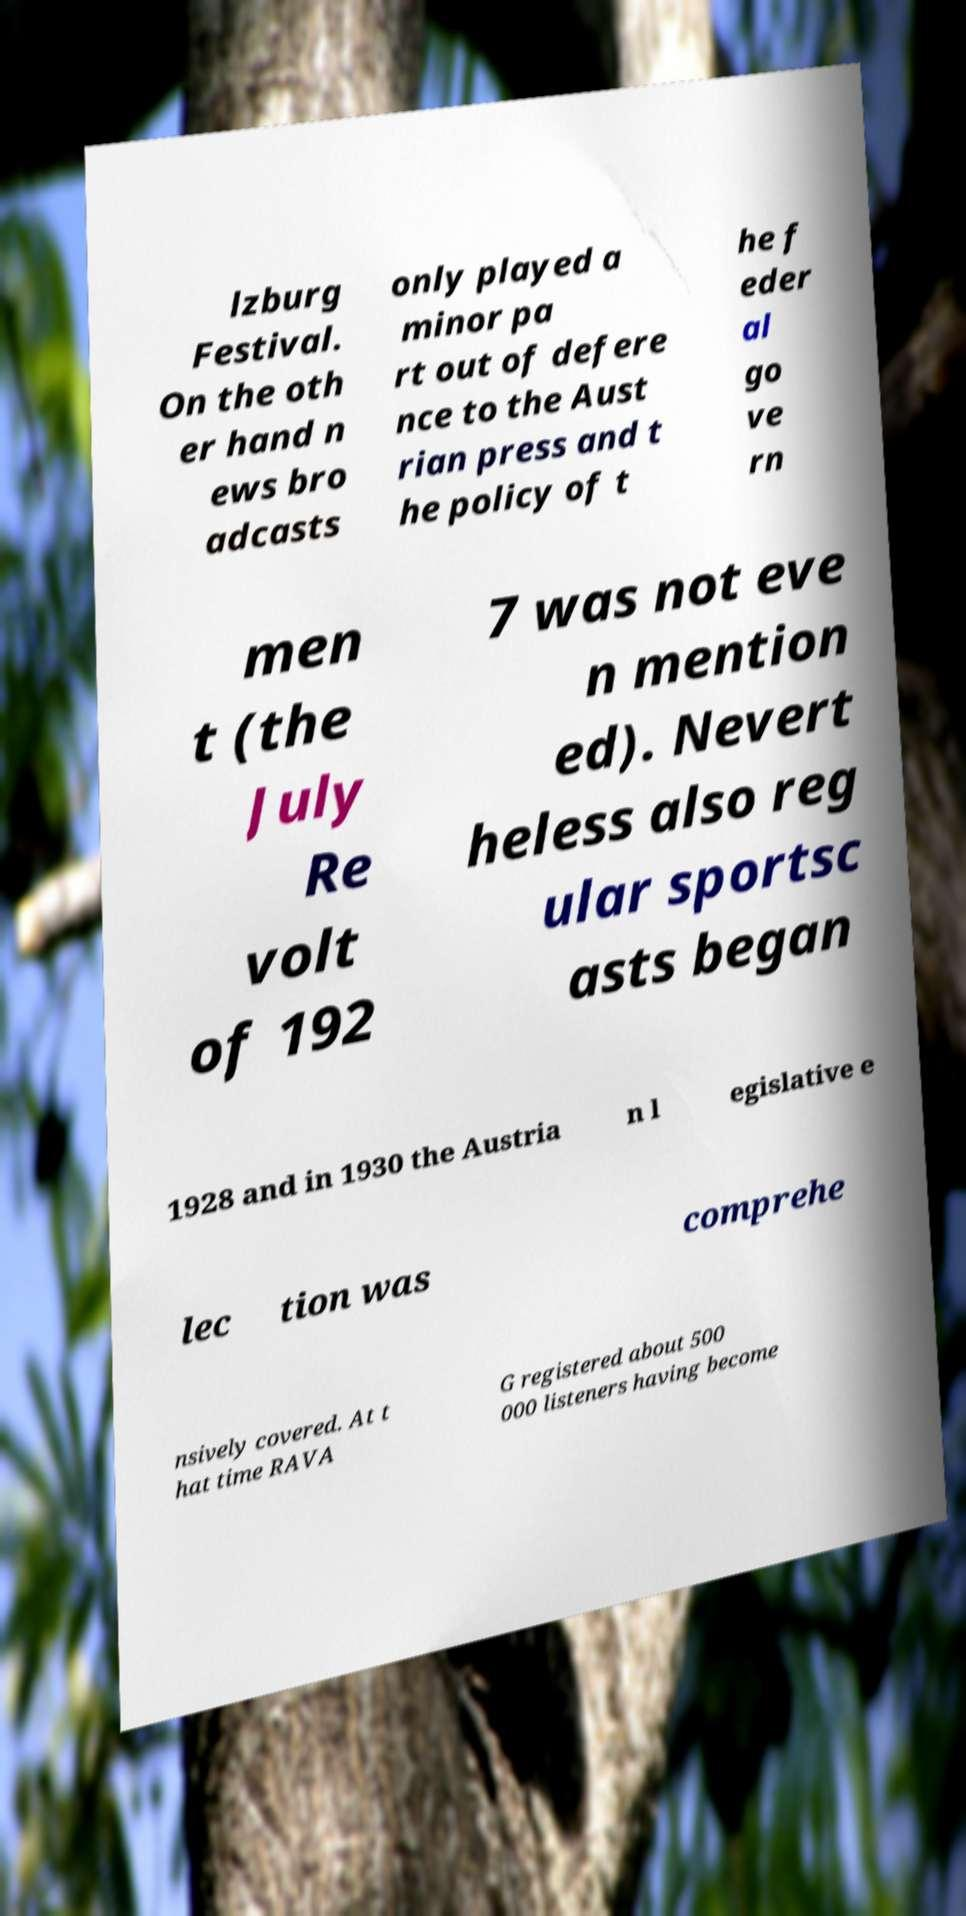Could you extract and type out the text from this image? lzburg Festival. On the oth er hand n ews bro adcasts only played a minor pa rt out of defere nce to the Aust rian press and t he policy of t he f eder al go ve rn men t (the July Re volt of 192 7 was not eve n mention ed). Nevert heless also reg ular sportsc asts began 1928 and in 1930 the Austria n l egislative e lec tion was comprehe nsively covered. At t hat time RAVA G registered about 500 000 listeners having become 